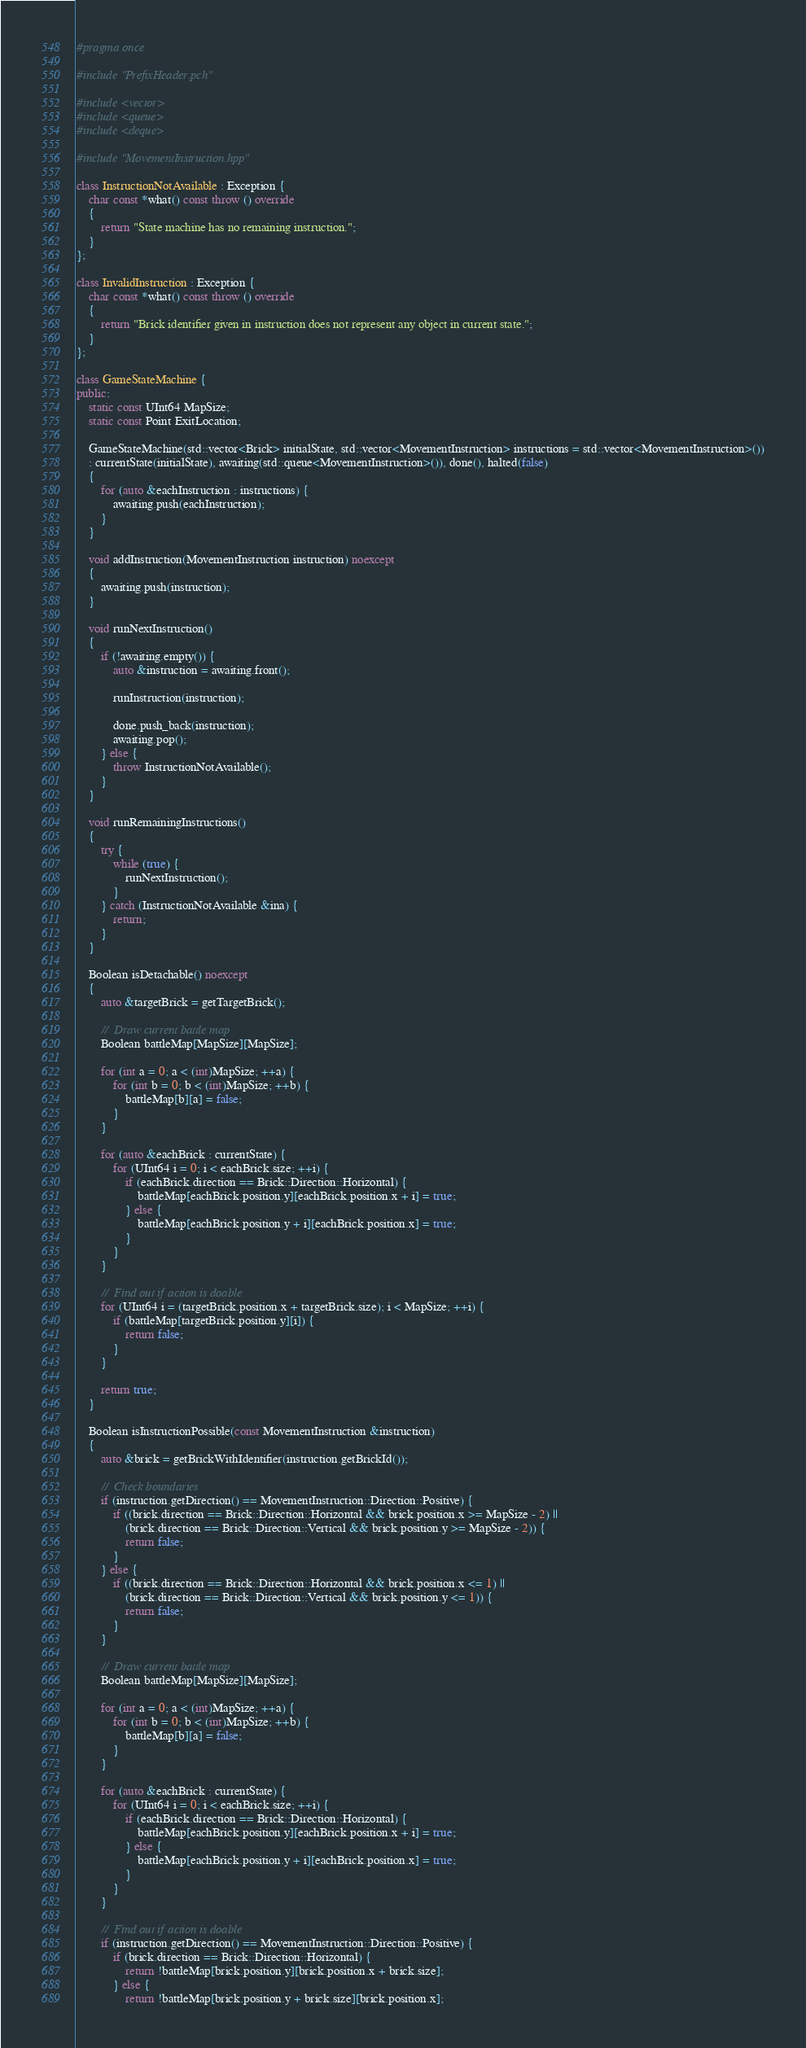<code> <loc_0><loc_0><loc_500><loc_500><_C++_>#pragma once

#include "PrefixHeader.pch"

#include <vector>
#include <queue>
#include <deque>

#include "MovementInstruction.hpp"

class InstructionNotAvailable : Exception {
    char const *what() const throw () override
    {
        return "State machine has no remaining instruction.";
    }
};

class InvalidInstruction : Exception {
    char const *what() const throw () override
    {
        return "Brick identifier given in instruction does not represent any object in current state.";
    }
};

class GameStateMachine {
public:
    static const UInt64 MapSize;
    static const Point ExitLocation;
    
    GameStateMachine(std::vector<Brick> initialState, std::vector<MovementInstruction> instructions = std::vector<MovementInstruction>())
    : currentState(initialState), awaiting(std::queue<MovementInstruction>()), done(), halted(false)
    {
        for (auto &eachInstruction : instructions) {
            awaiting.push(eachInstruction);
        }
    }
    
    void addInstruction(MovementInstruction instruction) noexcept
    {
        awaiting.push(instruction);
    }
    
    void runNextInstruction()
    {
        if (!awaiting.empty()) {
            auto &instruction = awaiting.front();
            
            runInstruction(instruction);
            
            done.push_back(instruction);
            awaiting.pop();
        } else {
            throw InstructionNotAvailable();
        }
    }
    
    void runRemainingInstructions()
    {
        try {
            while (true) {
                runNextInstruction();
            }
        } catch (InstructionNotAvailable &ina) {
            return;
        }
    }
    
    Boolean isDetachable() noexcept
    {
        auto &targetBrick = getTargetBrick();
        
        //  Draw current battle map
        Boolean battleMap[MapSize][MapSize];
        
        for (int a = 0; a < (int)MapSize; ++a) {
            for (int b = 0; b < (int)MapSize; ++b) {
                battleMap[b][a] = false;
            }
        }
        
        for (auto &eachBrick : currentState) {
            for (UInt64 i = 0; i < eachBrick.size; ++i) {
                if (eachBrick.direction == Brick::Direction::Horizontal) {
                    battleMap[eachBrick.position.y][eachBrick.position.x + i] = true;
                } else {
                    battleMap[eachBrick.position.y + i][eachBrick.position.x] = true;
                }
            }
        }
        
        //  Find out if action is doable
        for (UInt64 i = (targetBrick.position.x + targetBrick.size); i < MapSize; ++i) {
            if (battleMap[targetBrick.position.y][i]) {
                return false;
            }
        }
        
        return true;
    }
    
    Boolean isInstructionPossible(const MovementInstruction &instruction)
    {
        auto &brick = getBrickWithIdentifier(instruction.getBrickId());
        
        //  Check boundaries
        if (instruction.getDirection() == MovementInstruction::Direction::Positive) {
            if ((brick.direction == Brick::Direction::Horizontal && brick.position.x >= MapSize - 2) ||
                (brick.direction == Brick::Direction::Vertical && brick.position.y >= MapSize - 2)) {
                return false;
            }
        } else {
            if ((brick.direction == Brick::Direction::Horizontal && brick.position.x <= 1) ||
                (brick.direction == Brick::Direction::Vertical && brick.position.y <= 1)) {
                return false;
            }
        }
        
        //  Draw current battle map
        Boolean battleMap[MapSize][MapSize];
        
        for (int a = 0; a < (int)MapSize; ++a) {
            for (int b = 0; b < (int)MapSize; ++b) {
                battleMap[b][a] = false;
            }
        }
        
        for (auto &eachBrick : currentState) {
            for (UInt64 i = 0; i < eachBrick.size; ++i) {
                if (eachBrick.direction == Brick::Direction::Horizontal) {
                    battleMap[eachBrick.position.y][eachBrick.position.x + i] = true;
                } else {
                    battleMap[eachBrick.position.y + i][eachBrick.position.x] = true;
                }
            }
        }
        
        //  Find out if action is doable
        if (instruction.getDirection() == MovementInstruction::Direction::Positive) {
            if (brick.direction == Brick::Direction::Horizontal) {
                return !battleMap[brick.position.y][brick.position.x + brick.size];
            } else {
                return !battleMap[brick.position.y + brick.size][brick.position.x];</code> 